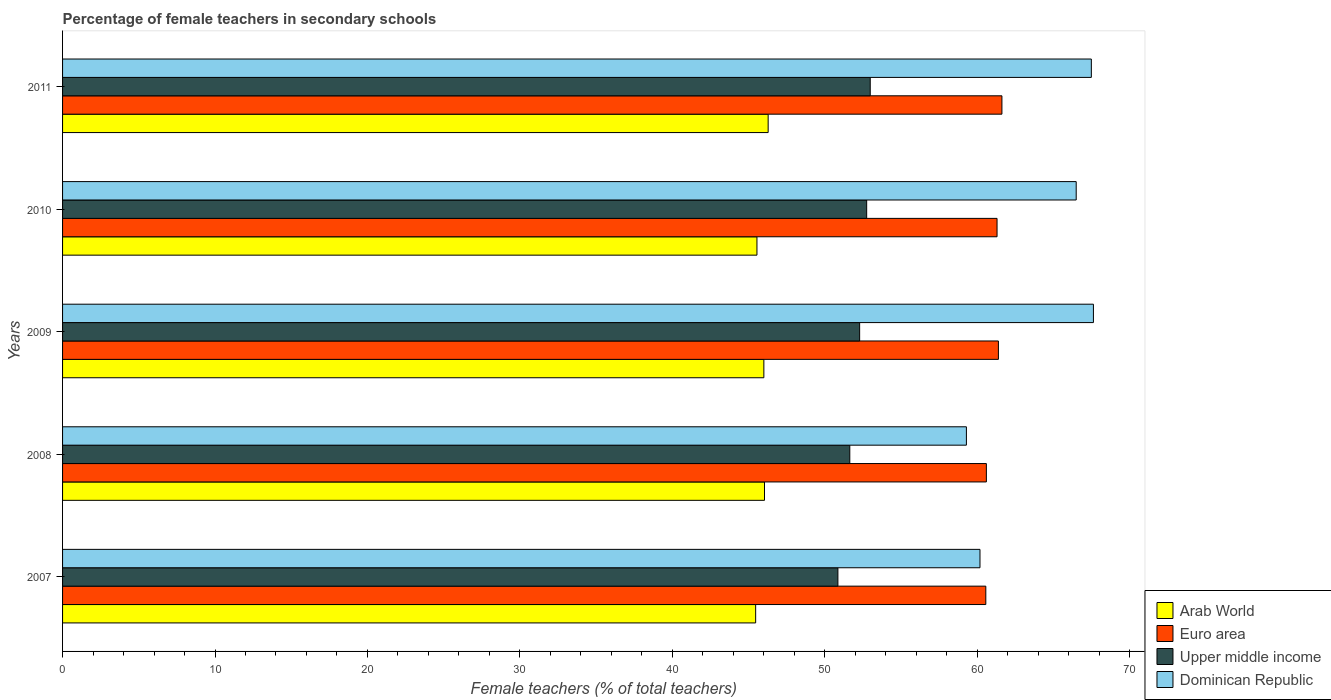How many different coloured bars are there?
Give a very brief answer. 4. How many groups of bars are there?
Offer a very short reply. 5. Are the number of bars per tick equal to the number of legend labels?
Your answer should be very brief. Yes. Are the number of bars on each tick of the Y-axis equal?
Offer a terse response. Yes. How many bars are there on the 1st tick from the bottom?
Your response must be concise. 4. What is the label of the 5th group of bars from the top?
Offer a very short reply. 2007. What is the percentage of female teachers in Arab World in 2009?
Your answer should be compact. 46. Across all years, what is the maximum percentage of female teachers in Dominican Republic?
Provide a short and direct response. 67.62. Across all years, what is the minimum percentage of female teachers in Arab World?
Your response must be concise. 45.46. In which year was the percentage of female teachers in Arab World maximum?
Provide a short and direct response. 2011. In which year was the percentage of female teachers in Euro area minimum?
Give a very brief answer. 2007. What is the total percentage of female teachers in Euro area in the graph?
Your answer should be compact. 305.47. What is the difference between the percentage of female teachers in Arab World in 2008 and that in 2010?
Your answer should be very brief. 0.5. What is the difference between the percentage of female teachers in Dominican Republic in 2010 and the percentage of female teachers in Euro area in 2007?
Your answer should be compact. 5.93. What is the average percentage of female teachers in Euro area per year?
Your answer should be very brief. 61.09. In the year 2011, what is the difference between the percentage of female teachers in Upper middle income and percentage of female teachers in Dominican Republic?
Keep it short and to the point. -14.5. What is the ratio of the percentage of female teachers in Dominican Republic in 2010 to that in 2011?
Provide a short and direct response. 0.99. Is the percentage of female teachers in Upper middle income in 2010 less than that in 2011?
Your answer should be compact. Yes. Is the difference between the percentage of female teachers in Upper middle income in 2007 and 2008 greater than the difference between the percentage of female teachers in Dominican Republic in 2007 and 2008?
Make the answer very short. No. What is the difference between the highest and the second highest percentage of female teachers in Euro area?
Provide a succinct answer. 0.23. What is the difference between the highest and the lowest percentage of female teachers in Arab World?
Offer a very short reply. 0.82. Is the sum of the percentage of female teachers in Upper middle income in 2009 and 2010 greater than the maximum percentage of female teachers in Euro area across all years?
Your answer should be compact. Yes. Is it the case that in every year, the sum of the percentage of female teachers in Euro area and percentage of female teachers in Arab World is greater than the sum of percentage of female teachers in Dominican Republic and percentage of female teachers in Upper middle income?
Provide a short and direct response. No. What does the 4th bar from the top in 2011 represents?
Keep it short and to the point. Arab World. What does the 1st bar from the bottom in 2007 represents?
Offer a very short reply. Arab World. Is it the case that in every year, the sum of the percentage of female teachers in Upper middle income and percentage of female teachers in Arab World is greater than the percentage of female teachers in Dominican Republic?
Offer a very short reply. Yes. How many years are there in the graph?
Provide a short and direct response. 5. Does the graph contain any zero values?
Your response must be concise. No. Does the graph contain grids?
Offer a terse response. No. How many legend labels are there?
Your answer should be compact. 4. How are the legend labels stacked?
Keep it short and to the point. Vertical. What is the title of the graph?
Keep it short and to the point. Percentage of female teachers in secondary schools. What is the label or title of the X-axis?
Provide a succinct answer. Female teachers (% of total teachers). What is the Female teachers (% of total teachers) in Arab World in 2007?
Provide a short and direct response. 45.46. What is the Female teachers (% of total teachers) of Euro area in 2007?
Provide a short and direct response. 60.56. What is the Female teachers (% of total teachers) in Upper middle income in 2007?
Provide a succinct answer. 50.86. What is the Female teachers (% of total teachers) in Dominican Republic in 2007?
Provide a short and direct response. 60.18. What is the Female teachers (% of total teachers) of Arab World in 2008?
Your answer should be compact. 46.04. What is the Female teachers (% of total teachers) in Euro area in 2008?
Your answer should be very brief. 60.6. What is the Female teachers (% of total teachers) in Upper middle income in 2008?
Give a very brief answer. 51.64. What is the Female teachers (% of total teachers) of Dominican Republic in 2008?
Your response must be concise. 59.29. What is the Female teachers (% of total teachers) of Arab World in 2009?
Give a very brief answer. 46. What is the Female teachers (% of total teachers) in Euro area in 2009?
Offer a terse response. 61.39. What is the Female teachers (% of total teachers) in Upper middle income in 2009?
Ensure brevity in your answer.  52.29. What is the Female teachers (% of total teachers) of Dominican Republic in 2009?
Your response must be concise. 67.62. What is the Female teachers (% of total teachers) in Arab World in 2010?
Offer a terse response. 45.55. What is the Female teachers (% of total teachers) of Euro area in 2010?
Your response must be concise. 61.3. What is the Female teachers (% of total teachers) of Upper middle income in 2010?
Provide a short and direct response. 52.75. What is the Female teachers (% of total teachers) of Dominican Republic in 2010?
Your answer should be compact. 66.49. What is the Female teachers (% of total teachers) in Arab World in 2011?
Give a very brief answer. 46.28. What is the Female teachers (% of total teachers) in Euro area in 2011?
Make the answer very short. 61.62. What is the Female teachers (% of total teachers) of Upper middle income in 2011?
Provide a succinct answer. 52.98. What is the Female teachers (% of total teachers) of Dominican Republic in 2011?
Keep it short and to the point. 67.48. Across all years, what is the maximum Female teachers (% of total teachers) of Arab World?
Ensure brevity in your answer.  46.28. Across all years, what is the maximum Female teachers (% of total teachers) in Euro area?
Your answer should be compact. 61.62. Across all years, what is the maximum Female teachers (% of total teachers) in Upper middle income?
Your answer should be compact. 52.98. Across all years, what is the maximum Female teachers (% of total teachers) in Dominican Republic?
Offer a very short reply. 67.62. Across all years, what is the minimum Female teachers (% of total teachers) of Arab World?
Offer a terse response. 45.46. Across all years, what is the minimum Female teachers (% of total teachers) of Euro area?
Keep it short and to the point. 60.56. Across all years, what is the minimum Female teachers (% of total teachers) of Upper middle income?
Give a very brief answer. 50.86. Across all years, what is the minimum Female teachers (% of total teachers) of Dominican Republic?
Your response must be concise. 59.29. What is the total Female teachers (% of total teachers) of Arab World in the graph?
Your response must be concise. 229.34. What is the total Female teachers (% of total teachers) of Euro area in the graph?
Ensure brevity in your answer.  305.47. What is the total Female teachers (% of total teachers) in Upper middle income in the graph?
Ensure brevity in your answer.  260.51. What is the total Female teachers (% of total teachers) of Dominican Republic in the graph?
Your answer should be very brief. 321.06. What is the difference between the Female teachers (% of total teachers) of Arab World in 2007 and that in 2008?
Provide a succinct answer. -0.58. What is the difference between the Female teachers (% of total teachers) in Euro area in 2007 and that in 2008?
Offer a very short reply. -0.04. What is the difference between the Female teachers (% of total teachers) of Upper middle income in 2007 and that in 2008?
Keep it short and to the point. -0.78. What is the difference between the Female teachers (% of total teachers) of Dominican Republic in 2007 and that in 2008?
Your answer should be very brief. 0.89. What is the difference between the Female teachers (% of total teachers) in Arab World in 2007 and that in 2009?
Offer a very short reply. -0.54. What is the difference between the Female teachers (% of total teachers) of Euro area in 2007 and that in 2009?
Your response must be concise. -0.83. What is the difference between the Female teachers (% of total teachers) in Upper middle income in 2007 and that in 2009?
Your answer should be very brief. -1.43. What is the difference between the Female teachers (% of total teachers) in Dominican Republic in 2007 and that in 2009?
Offer a very short reply. -7.44. What is the difference between the Female teachers (% of total teachers) of Arab World in 2007 and that in 2010?
Offer a very short reply. -0.08. What is the difference between the Female teachers (% of total teachers) in Euro area in 2007 and that in 2010?
Provide a short and direct response. -0.74. What is the difference between the Female teachers (% of total teachers) in Upper middle income in 2007 and that in 2010?
Keep it short and to the point. -1.89. What is the difference between the Female teachers (% of total teachers) in Dominican Republic in 2007 and that in 2010?
Your answer should be compact. -6.31. What is the difference between the Female teachers (% of total teachers) in Arab World in 2007 and that in 2011?
Offer a terse response. -0.82. What is the difference between the Female teachers (% of total teachers) of Euro area in 2007 and that in 2011?
Offer a very short reply. -1.06. What is the difference between the Female teachers (% of total teachers) of Upper middle income in 2007 and that in 2011?
Offer a terse response. -2.12. What is the difference between the Female teachers (% of total teachers) in Dominican Republic in 2007 and that in 2011?
Ensure brevity in your answer.  -7.3. What is the difference between the Female teachers (% of total teachers) of Arab World in 2008 and that in 2009?
Make the answer very short. 0.04. What is the difference between the Female teachers (% of total teachers) in Euro area in 2008 and that in 2009?
Ensure brevity in your answer.  -0.79. What is the difference between the Female teachers (% of total teachers) of Upper middle income in 2008 and that in 2009?
Make the answer very short. -0.65. What is the difference between the Female teachers (% of total teachers) of Dominican Republic in 2008 and that in 2009?
Provide a short and direct response. -8.33. What is the difference between the Female teachers (% of total teachers) of Arab World in 2008 and that in 2010?
Ensure brevity in your answer.  0.5. What is the difference between the Female teachers (% of total teachers) of Upper middle income in 2008 and that in 2010?
Offer a very short reply. -1.11. What is the difference between the Female teachers (% of total teachers) of Dominican Republic in 2008 and that in 2010?
Your answer should be compact. -7.2. What is the difference between the Female teachers (% of total teachers) of Arab World in 2008 and that in 2011?
Keep it short and to the point. -0.24. What is the difference between the Female teachers (% of total teachers) in Euro area in 2008 and that in 2011?
Provide a short and direct response. -1.02. What is the difference between the Female teachers (% of total teachers) in Upper middle income in 2008 and that in 2011?
Offer a terse response. -1.34. What is the difference between the Female teachers (% of total teachers) in Dominican Republic in 2008 and that in 2011?
Offer a very short reply. -8.2. What is the difference between the Female teachers (% of total teachers) in Arab World in 2009 and that in 2010?
Offer a very short reply. 0.45. What is the difference between the Female teachers (% of total teachers) in Euro area in 2009 and that in 2010?
Your answer should be very brief. 0.09. What is the difference between the Female teachers (% of total teachers) of Upper middle income in 2009 and that in 2010?
Give a very brief answer. -0.46. What is the difference between the Female teachers (% of total teachers) of Dominican Republic in 2009 and that in 2010?
Your response must be concise. 1.13. What is the difference between the Female teachers (% of total teachers) of Arab World in 2009 and that in 2011?
Your response must be concise. -0.28. What is the difference between the Female teachers (% of total teachers) of Euro area in 2009 and that in 2011?
Keep it short and to the point. -0.23. What is the difference between the Female teachers (% of total teachers) in Upper middle income in 2009 and that in 2011?
Ensure brevity in your answer.  -0.7. What is the difference between the Female teachers (% of total teachers) of Dominican Republic in 2009 and that in 2011?
Give a very brief answer. 0.14. What is the difference between the Female teachers (% of total teachers) in Arab World in 2010 and that in 2011?
Your answer should be compact. -0.73. What is the difference between the Female teachers (% of total teachers) in Euro area in 2010 and that in 2011?
Provide a succinct answer. -0.32. What is the difference between the Female teachers (% of total teachers) of Upper middle income in 2010 and that in 2011?
Offer a terse response. -0.23. What is the difference between the Female teachers (% of total teachers) in Dominican Republic in 2010 and that in 2011?
Provide a succinct answer. -0.99. What is the difference between the Female teachers (% of total teachers) in Arab World in 2007 and the Female teachers (% of total teachers) in Euro area in 2008?
Provide a short and direct response. -15.13. What is the difference between the Female teachers (% of total teachers) of Arab World in 2007 and the Female teachers (% of total teachers) of Upper middle income in 2008?
Provide a succinct answer. -6.18. What is the difference between the Female teachers (% of total teachers) of Arab World in 2007 and the Female teachers (% of total teachers) of Dominican Republic in 2008?
Provide a short and direct response. -13.82. What is the difference between the Female teachers (% of total teachers) in Euro area in 2007 and the Female teachers (% of total teachers) in Upper middle income in 2008?
Your answer should be very brief. 8.92. What is the difference between the Female teachers (% of total teachers) in Euro area in 2007 and the Female teachers (% of total teachers) in Dominican Republic in 2008?
Offer a very short reply. 1.27. What is the difference between the Female teachers (% of total teachers) of Upper middle income in 2007 and the Female teachers (% of total teachers) of Dominican Republic in 2008?
Ensure brevity in your answer.  -8.43. What is the difference between the Female teachers (% of total teachers) in Arab World in 2007 and the Female teachers (% of total teachers) in Euro area in 2009?
Your answer should be compact. -15.92. What is the difference between the Female teachers (% of total teachers) in Arab World in 2007 and the Female teachers (% of total teachers) in Upper middle income in 2009?
Give a very brief answer. -6.82. What is the difference between the Female teachers (% of total teachers) of Arab World in 2007 and the Female teachers (% of total teachers) of Dominican Republic in 2009?
Make the answer very short. -22.16. What is the difference between the Female teachers (% of total teachers) in Euro area in 2007 and the Female teachers (% of total teachers) in Upper middle income in 2009?
Make the answer very short. 8.28. What is the difference between the Female teachers (% of total teachers) in Euro area in 2007 and the Female teachers (% of total teachers) in Dominican Republic in 2009?
Ensure brevity in your answer.  -7.06. What is the difference between the Female teachers (% of total teachers) in Upper middle income in 2007 and the Female teachers (% of total teachers) in Dominican Republic in 2009?
Give a very brief answer. -16.76. What is the difference between the Female teachers (% of total teachers) of Arab World in 2007 and the Female teachers (% of total teachers) of Euro area in 2010?
Provide a succinct answer. -15.83. What is the difference between the Female teachers (% of total teachers) in Arab World in 2007 and the Female teachers (% of total teachers) in Upper middle income in 2010?
Provide a succinct answer. -7.28. What is the difference between the Female teachers (% of total teachers) in Arab World in 2007 and the Female teachers (% of total teachers) in Dominican Republic in 2010?
Keep it short and to the point. -21.03. What is the difference between the Female teachers (% of total teachers) of Euro area in 2007 and the Female teachers (% of total teachers) of Upper middle income in 2010?
Offer a terse response. 7.82. What is the difference between the Female teachers (% of total teachers) in Euro area in 2007 and the Female teachers (% of total teachers) in Dominican Republic in 2010?
Give a very brief answer. -5.93. What is the difference between the Female teachers (% of total teachers) in Upper middle income in 2007 and the Female teachers (% of total teachers) in Dominican Republic in 2010?
Your response must be concise. -15.63. What is the difference between the Female teachers (% of total teachers) of Arab World in 2007 and the Female teachers (% of total teachers) of Euro area in 2011?
Offer a very short reply. -16.15. What is the difference between the Female teachers (% of total teachers) of Arab World in 2007 and the Female teachers (% of total teachers) of Upper middle income in 2011?
Provide a short and direct response. -7.52. What is the difference between the Female teachers (% of total teachers) in Arab World in 2007 and the Female teachers (% of total teachers) in Dominican Republic in 2011?
Provide a short and direct response. -22.02. What is the difference between the Female teachers (% of total teachers) of Euro area in 2007 and the Female teachers (% of total teachers) of Upper middle income in 2011?
Make the answer very short. 7.58. What is the difference between the Female teachers (% of total teachers) in Euro area in 2007 and the Female teachers (% of total teachers) in Dominican Republic in 2011?
Ensure brevity in your answer.  -6.92. What is the difference between the Female teachers (% of total teachers) of Upper middle income in 2007 and the Female teachers (% of total teachers) of Dominican Republic in 2011?
Make the answer very short. -16.62. What is the difference between the Female teachers (% of total teachers) in Arab World in 2008 and the Female teachers (% of total teachers) in Euro area in 2009?
Your answer should be compact. -15.34. What is the difference between the Female teachers (% of total teachers) of Arab World in 2008 and the Female teachers (% of total teachers) of Upper middle income in 2009?
Your answer should be very brief. -6.24. What is the difference between the Female teachers (% of total teachers) in Arab World in 2008 and the Female teachers (% of total teachers) in Dominican Republic in 2009?
Provide a short and direct response. -21.58. What is the difference between the Female teachers (% of total teachers) in Euro area in 2008 and the Female teachers (% of total teachers) in Upper middle income in 2009?
Offer a terse response. 8.31. What is the difference between the Female teachers (% of total teachers) of Euro area in 2008 and the Female teachers (% of total teachers) of Dominican Republic in 2009?
Your answer should be compact. -7.02. What is the difference between the Female teachers (% of total teachers) in Upper middle income in 2008 and the Female teachers (% of total teachers) in Dominican Republic in 2009?
Your answer should be very brief. -15.98. What is the difference between the Female teachers (% of total teachers) of Arab World in 2008 and the Female teachers (% of total teachers) of Euro area in 2010?
Offer a very short reply. -15.25. What is the difference between the Female teachers (% of total teachers) in Arab World in 2008 and the Female teachers (% of total teachers) in Upper middle income in 2010?
Ensure brevity in your answer.  -6.7. What is the difference between the Female teachers (% of total teachers) of Arab World in 2008 and the Female teachers (% of total teachers) of Dominican Republic in 2010?
Offer a terse response. -20.45. What is the difference between the Female teachers (% of total teachers) of Euro area in 2008 and the Female teachers (% of total teachers) of Upper middle income in 2010?
Keep it short and to the point. 7.85. What is the difference between the Female teachers (% of total teachers) in Euro area in 2008 and the Female teachers (% of total teachers) in Dominican Republic in 2010?
Your answer should be very brief. -5.89. What is the difference between the Female teachers (% of total teachers) of Upper middle income in 2008 and the Female teachers (% of total teachers) of Dominican Republic in 2010?
Offer a terse response. -14.85. What is the difference between the Female teachers (% of total teachers) of Arab World in 2008 and the Female teachers (% of total teachers) of Euro area in 2011?
Ensure brevity in your answer.  -15.57. What is the difference between the Female teachers (% of total teachers) in Arab World in 2008 and the Female teachers (% of total teachers) in Upper middle income in 2011?
Keep it short and to the point. -6.94. What is the difference between the Female teachers (% of total teachers) in Arab World in 2008 and the Female teachers (% of total teachers) in Dominican Republic in 2011?
Offer a terse response. -21.44. What is the difference between the Female teachers (% of total teachers) of Euro area in 2008 and the Female teachers (% of total teachers) of Upper middle income in 2011?
Offer a terse response. 7.62. What is the difference between the Female teachers (% of total teachers) of Euro area in 2008 and the Female teachers (% of total teachers) of Dominican Republic in 2011?
Offer a terse response. -6.88. What is the difference between the Female teachers (% of total teachers) in Upper middle income in 2008 and the Female teachers (% of total teachers) in Dominican Republic in 2011?
Offer a terse response. -15.84. What is the difference between the Female teachers (% of total teachers) in Arab World in 2009 and the Female teachers (% of total teachers) in Euro area in 2010?
Offer a terse response. -15.3. What is the difference between the Female teachers (% of total teachers) of Arab World in 2009 and the Female teachers (% of total teachers) of Upper middle income in 2010?
Keep it short and to the point. -6.74. What is the difference between the Female teachers (% of total teachers) of Arab World in 2009 and the Female teachers (% of total teachers) of Dominican Republic in 2010?
Ensure brevity in your answer.  -20.49. What is the difference between the Female teachers (% of total teachers) in Euro area in 2009 and the Female teachers (% of total teachers) in Upper middle income in 2010?
Your answer should be very brief. 8.64. What is the difference between the Female teachers (% of total teachers) of Euro area in 2009 and the Female teachers (% of total teachers) of Dominican Republic in 2010?
Your answer should be very brief. -5.1. What is the difference between the Female teachers (% of total teachers) in Upper middle income in 2009 and the Female teachers (% of total teachers) in Dominican Republic in 2010?
Keep it short and to the point. -14.21. What is the difference between the Female teachers (% of total teachers) of Arab World in 2009 and the Female teachers (% of total teachers) of Euro area in 2011?
Provide a short and direct response. -15.62. What is the difference between the Female teachers (% of total teachers) of Arab World in 2009 and the Female teachers (% of total teachers) of Upper middle income in 2011?
Your answer should be compact. -6.98. What is the difference between the Female teachers (% of total teachers) in Arab World in 2009 and the Female teachers (% of total teachers) in Dominican Republic in 2011?
Provide a succinct answer. -21.48. What is the difference between the Female teachers (% of total teachers) of Euro area in 2009 and the Female teachers (% of total teachers) of Upper middle income in 2011?
Your answer should be compact. 8.41. What is the difference between the Female teachers (% of total teachers) of Euro area in 2009 and the Female teachers (% of total teachers) of Dominican Republic in 2011?
Make the answer very short. -6.1. What is the difference between the Female teachers (% of total teachers) of Upper middle income in 2009 and the Female teachers (% of total teachers) of Dominican Republic in 2011?
Provide a succinct answer. -15.2. What is the difference between the Female teachers (% of total teachers) in Arab World in 2010 and the Female teachers (% of total teachers) in Euro area in 2011?
Provide a succinct answer. -16.07. What is the difference between the Female teachers (% of total teachers) of Arab World in 2010 and the Female teachers (% of total teachers) of Upper middle income in 2011?
Keep it short and to the point. -7.43. What is the difference between the Female teachers (% of total teachers) of Arab World in 2010 and the Female teachers (% of total teachers) of Dominican Republic in 2011?
Offer a very short reply. -21.93. What is the difference between the Female teachers (% of total teachers) of Euro area in 2010 and the Female teachers (% of total teachers) of Upper middle income in 2011?
Keep it short and to the point. 8.32. What is the difference between the Female teachers (% of total teachers) in Euro area in 2010 and the Female teachers (% of total teachers) in Dominican Republic in 2011?
Your response must be concise. -6.18. What is the difference between the Female teachers (% of total teachers) in Upper middle income in 2010 and the Female teachers (% of total teachers) in Dominican Republic in 2011?
Offer a terse response. -14.74. What is the average Female teachers (% of total teachers) of Arab World per year?
Your answer should be compact. 45.87. What is the average Female teachers (% of total teachers) in Euro area per year?
Ensure brevity in your answer.  61.09. What is the average Female teachers (% of total teachers) in Upper middle income per year?
Give a very brief answer. 52.1. What is the average Female teachers (% of total teachers) in Dominican Republic per year?
Provide a short and direct response. 64.21. In the year 2007, what is the difference between the Female teachers (% of total teachers) in Arab World and Female teachers (% of total teachers) in Euro area?
Give a very brief answer. -15.1. In the year 2007, what is the difference between the Female teachers (% of total teachers) in Arab World and Female teachers (% of total teachers) in Upper middle income?
Your answer should be compact. -5.39. In the year 2007, what is the difference between the Female teachers (% of total teachers) in Arab World and Female teachers (% of total teachers) in Dominican Republic?
Ensure brevity in your answer.  -14.72. In the year 2007, what is the difference between the Female teachers (% of total teachers) in Euro area and Female teachers (% of total teachers) in Upper middle income?
Your response must be concise. 9.7. In the year 2007, what is the difference between the Female teachers (% of total teachers) in Euro area and Female teachers (% of total teachers) in Dominican Republic?
Offer a very short reply. 0.38. In the year 2007, what is the difference between the Female teachers (% of total teachers) of Upper middle income and Female teachers (% of total teachers) of Dominican Republic?
Make the answer very short. -9.32. In the year 2008, what is the difference between the Female teachers (% of total teachers) of Arab World and Female teachers (% of total teachers) of Euro area?
Provide a short and direct response. -14.55. In the year 2008, what is the difference between the Female teachers (% of total teachers) of Arab World and Female teachers (% of total teachers) of Upper middle income?
Ensure brevity in your answer.  -5.6. In the year 2008, what is the difference between the Female teachers (% of total teachers) of Arab World and Female teachers (% of total teachers) of Dominican Republic?
Provide a short and direct response. -13.24. In the year 2008, what is the difference between the Female teachers (% of total teachers) in Euro area and Female teachers (% of total teachers) in Upper middle income?
Your response must be concise. 8.96. In the year 2008, what is the difference between the Female teachers (% of total teachers) in Euro area and Female teachers (% of total teachers) in Dominican Republic?
Make the answer very short. 1.31. In the year 2008, what is the difference between the Female teachers (% of total teachers) of Upper middle income and Female teachers (% of total teachers) of Dominican Republic?
Offer a very short reply. -7.65. In the year 2009, what is the difference between the Female teachers (% of total teachers) in Arab World and Female teachers (% of total teachers) in Euro area?
Give a very brief answer. -15.39. In the year 2009, what is the difference between the Female teachers (% of total teachers) of Arab World and Female teachers (% of total teachers) of Upper middle income?
Offer a terse response. -6.28. In the year 2009, what is the difference between the Female teachers (% of total teachers) in Arab World and Female teachers (% of total teachers) in Dominican Republic?
Your response must be concise. -21.62. In the year 2009, what is the difference between the Female teachers (% of total teachers) in Euro area and Female teachers (% of total teachers) in Upper middle income?
Offer a terse response. 9.1. In the year 2009, what is the difference between the Female teachers (% of total teachers) of Euro area and Female teachers (% of total teachers) of Dominican Republic?
Provide a short and direct response. -6.23. In the year 2009, what is the difference between the Female teachers (% of total teachers) in Upper middle income and Female teachers (% of total teachers) in Dominican Republic?
Provide a succinct answer. -15.34. In the year 2010, what is the difference between the Female teachers (% of total teachers) in Arab World and Female teachers (% of total teachers) in Euro area?
Your answer should be very brief. -15.75. In the year 2010, what is the difference between the Female teachers (% of total teachers) of Arab World and Female teachers (% of total teachers) of Upper middle income?
Your answer should be very brief. -7.2. In the year 2010, what is the difference between the Female teachers (% of total teachers) in Arab World and Female teachers (% of total teachers) in Dominican Republic?
Your response must be concise. -20.94. In the year 2010, what is the difference between the Female teachers (% of total teachers) of Euro area and Female teachers (% of total teachers) of Upper middle income?
Provide a short and direct response. 8.55. In the year 2010, what is the difference between the Female teachers (% of total teachers) in Euro area and Female teachers (% of total teachers) in Dominican Republic?
Offer a very short reply. -5.19. In the year 2010, what is the difference between the Female teachers (% of total teachers) of Upper middle income and Female teachers (% of total teachers) of Dominican Republic?
Offer a very short reply. -13.74. In the year 2011, what is the difference between the Female teachers (% of total teachers) of Arab World and Female teachers (% of total teachers) of Euro area?
Offer a very short reply. -15.33. In the year 2011, what is the difference between the Female teachers (% of total teachers) in Arab World and Female teachers (% of total teachers) in Upper middle income?
Ensure brevity in your answer.  -6.7. In the year 2011, what is the difference between the Female teachers (% of total teachers) in Arab World and Female teachers (% of total teachers) in Dominican Republic?
Ensure brevity in your answer.  -21.2. In the year 2011, what is the difference between the Female teachers (% of total teachers) in Euro area and Female teachers (% of total teachers) in Upper middle income?
Keep it short and to the point. 8.64. In the year 2011, what is the difference between the Female teachers (% of total teachers) of Euro area and Female teachers (% of total teachers) of Dominican Republic?
Offer a terse response. -5.87. In the year 2011, what is the difference between the Female teachers (% of total teachers) in Upper middle income and Female teachers (% of total teachers) in Dominican Republic?
Your response must be concise. -14.5. What is the ratio of the Female teachers (% of total teachers) in Arab World in 2007 to that in 2008?
Your response must be concise. 0.99. What is the ratio of the Female teachers (% of total teachers) in Euro area in 2007 to that in 2008?
Give a very brief answer. 1. What is the ratio of the Female teachers (% of total teachers) in Upper middle income in 2007 to that in 2008?
Give a very brief answer. 0.98. What is the ratio of the Female teachers (% of total teachers) in Arab World in 2007 to that in 2009?
Your answer should be very brief. 0.99. What is the ratio of the Female teachers (% of total teachers) in Euro area in 2007 to that in 2009?
Ensure brevity in your answer.  0.99. What is the ratio of the Female teachers (% of total teachers) in Upper middle income in 2007 to that in 2009?
Your response must be concise. 0.97. What is the ratio of the Female teachers (% of total teachers) of Dominican Republic in 2007 to that in 2009?
Ensure brevity in your answer.  0.89. What is the ratio of the Female teachers (% of total teachers) of Upper middle income in 2007 to that in 2010?
Your response must be concise. 0.96. What is the ratio of the Female teachers (% of total teachers) of Dominican Republic in 2007 to that in 2010?
Your response must be concise. 0.91. What is the ratio of the Female teachers (% of total teachers) in Arab World in 2007 to that in 2011?
Your response must be concise. 0.98. What is the ratio of the Female teachers (% of total teachers) in Euro area in 2007 to that in 2011?
Ensure brevity in your answer.  0.98. What is the ratio of the Female teachers (% of total teachers) in Upper middle income in 2007 to that in 2011?
Your response must be concise. 0.96. What is the ratio of the Female teachers (% of total teachers) in Dominican Republic in 2007 to that in 2011?
Provide a short and direct response. 0.89. What is the ratio of the Female teachers (% of total teachers) in Arab World in 2008 to that in 2009?
Provide a short and direct response. 1. What is the ratio of the Female teachers (% of total teachers) in Euro area in 2008 to that in 2009?
Ensure brevity in your answer.  0.99. What is the ratio of the Female teachers (% of total teachers) of Dominican Republic in 2008 to that in 2009?
Make the answer very short. 0.88. What is the ratio of the Female teachers (% of total teachers) in Arab World in 2008 to that in 2010?
Offer a terse response. 1.01. What is the ratio of the Female teachers (% of total teachers) of Euro area in 2008 to that in 2010?
Ensure brevity in your answer.  0.99. What is the ratio of the Female teachers (% of total teachers) of Dominican Republic in 2008 to that in 2010?
Your answer should be very brief. 0.89. What is the ratio of the Female teachers (% of total teachers) in Arab World in 2008 to that in 2011?
Your answer should be compact. 0.99. What is the ratio of the Female teachers (% of total teachers) of Euro area in 2008 to that in 2011?
Offer a terse response. 0.98. What is the ratio of the Female teachers (% of total teachers) in Upper middle income in 2008 to that in 2011?
Provide a short and direct response. 0.97. What is the ratio of the Female teachers (% of total teachers) in Dominican Republic in 2008 to that in 2011?
Your answer should be compact. 0.88. What is the ratio of the Female teachers (% of total teachers) of Arab World in 2009 to that in 2010?
Keep it short and to the point. 1.01. What is the ratio of the Female teachers (% of total teachers) in Upper middle income in 2009 to that in 2010?
Your answer should be compact. 0.99. What is the ratio of the Female teachers (% of total teachers) of Euro area in 2009 to that in 2011?
Make the answer very short. 1. What is the ratio of the Female teachers (% of total teachers) of Upper middle income in 2009 to that in 2011?
Your answer should be very brief. 0.99. What is the ratio of the Female teachers (% of total teachers) in Dominican Republic in 2009 to that in 2011?
Ensure brevity in your answer.  1. What is the ratio of the Female teachers (% of total teachers) in Arab World in 2010 to that in 2011?
Provide a succinct answer. 0.98. What is the difference between the highest and the second highest Female teachers (% of total teachers) of Arab World?
Provide a short and direct response. 0.24. What is the difference between the highest and the second highest Female teachers (% of total teachers) in Euro area?
Provide a short and direct response. 0.23. What is the difference between the highest and the second highest Female teachers (% of total teachers) in Upper middle income?
Keep it short and to the point. 0.23. What is the difference between the highest and the second highest Female teachers (% of total teachers) of Dominican Republic?
Make the answer very short. 0.14. What is the difference between the highest and the lowest Female teachers (% of total teachers) of Arab World?
Keep it short and to the point. 0.82. What is the difference between the highest and the lowest Female teachers (% of total teachers) in Euro area?
Your answer should be very brief. 1.06. What is the difference between the highest and the lowest Female teachers (% of total teachers) of Upper middle income?
Give a very brief answer. 2.12. What is the difference between the highest and the lowest Female teachers (% of total teachers) of Dominican Republic?
Provide a succinct answer. 8.33. 